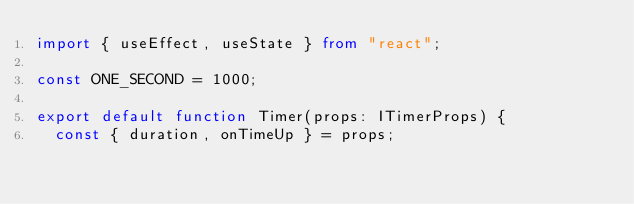<code> <loc_0><loc_0><loc_500><loc_500><_TypeScript_>import { useEffect, useState } from "react";

const ONE_SECOND = 1000;

export default function Timer(props: ITimerProps) {
  const { duration, onTimeUp } = props;</code> 